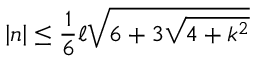Convert formula to latex. <formula><loc_0><loc_0><loc_500><loc_500>\left | n \right | \leq \frac { 1 } { 6 } \ell \sqrt { 6 + 3 \sqrt { 4 + k ^ { 2 } } }</formula> 